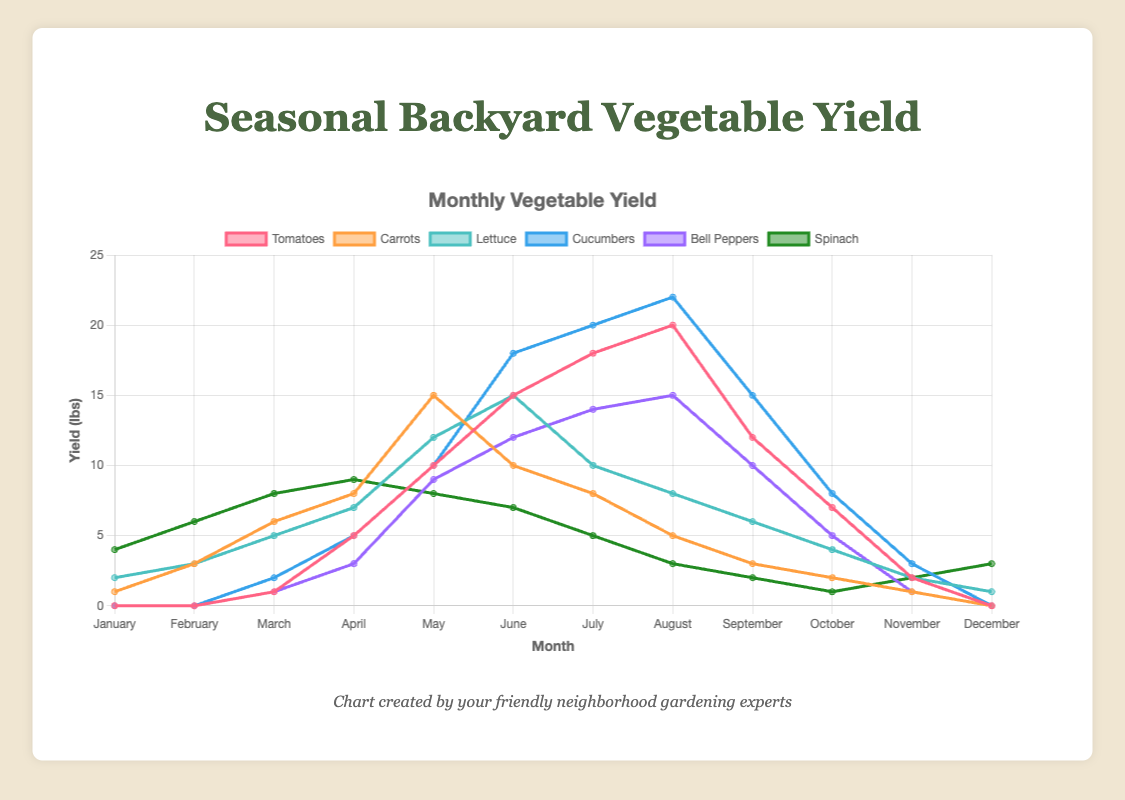Which vegetable has the highest yield in June? Look for the vegetable with the tallest line segment in June, which is Cucumbers.
Answer: Cucumbers What is the difference in yield between Bell Peppers and Spinach in August? Bell Peppers yield 15 units while Spinach yields 3 in August. The difference is 15 - 3 = 12.
Answer: 12 Compare the yields of Tomatoes and Carrots in April. Which has a higher yield? The line for Tomatoes reaches 5 units, and the line for Carrots reaches 8 units in April. Carrots have a higher yield.
Answer: Carrots What month do Lettuce yields peak, and what is the value? The highest point for the Lettuce line occurs in June at 15 units.
Answer: June, 15 Calculate the average yield of Cucumbers from May to July. The yields are 10 in May, 18 in June, and 20 in July. The sum is 10 + 18 + 20 = 48, and the average is 48 / 3 = 16.
Answer: 16 During which months does Spinach have a yield of 8 or higher? Spinach has a yield of 8 or higher in January, February, March, April, and May.
Answer: January, February, March, April, May What is the total yield of Tomatoes from March through May? The yields are 1 in March, 5 in April, and 10 in May. The total is 1 + 5 + 10 = 16.
Answer: 16 Which vegetable consistently shows a decline in yield from July to December? Reviewing each vegetable, Spinach shows a decline from 5 in July to 3 in December.
Answer: Spinach Compare the yields of Cucumbers and Tomatoes throughout the year. Which has more months with higher yields? Cucumbers have higher yields in March, June, July, August, September, and October, while Tomatoes have higher yields in April, May, and November. Cucumbers have higher yields in more months.
Answer: Cucumbers In which month do Bell Peppers start yielding for the first time, and what is the trend afterward? Bell Peppers start yielding in March with 1 unit. The yield generally increases with occasional fluctuations until it peaks in August.
Answer: March, increasing trend 